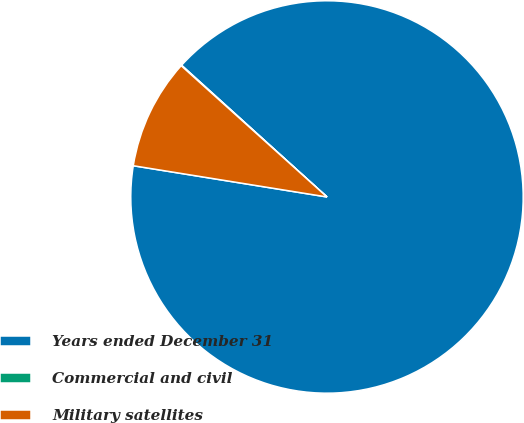<chart> <loc_0><loc_0><loc_500><loc_500><pie_chart><fcel>Years ended December 31<fcel>Commercial and civil<fcel>Military satellites<nl><fcel>90.83%<fcel>0.05%<fcel>9.12%<nl></chart> 